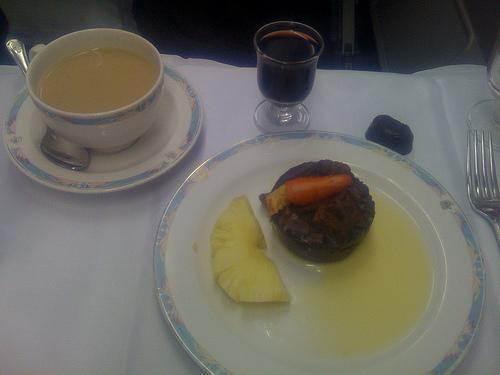How many forks are there?
Give a very brief answer. 1. 